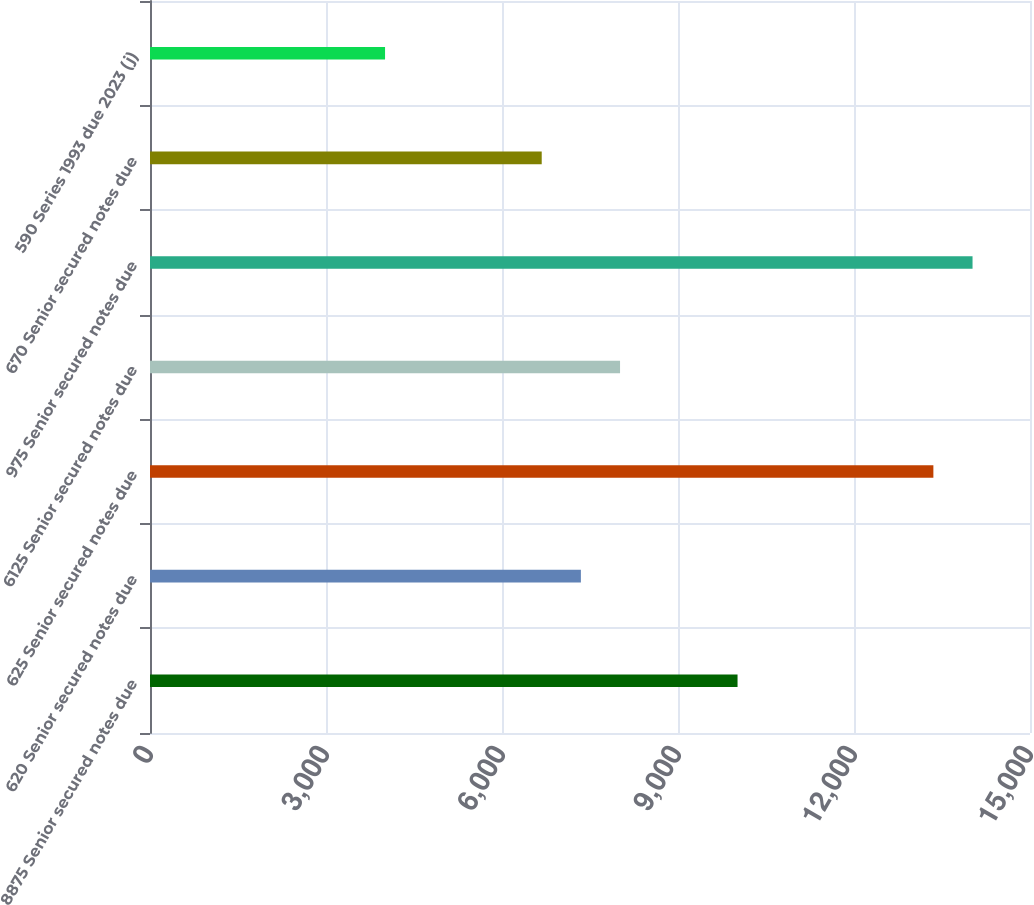Convert chart. <chart><loc_0><loc_0><loc_500><loc_500><bar_chart><fcel>8875 Senior secured notes due<fcel>620 Senior secured notes due<fcel>625 Senior secured notes due<fcel>6125 Senior secured notes due<fcel>975 Senior secured notes due<fcel>670 Senior secured notes due<fcel>590 Series 1993 due 2023 (j)<nl><fcel>10015<fcel>7344.6<fcel>13353<fcel>8012.2<fcel>14020.6<fcel>6677<fcel>4006.6<nl></chart> 